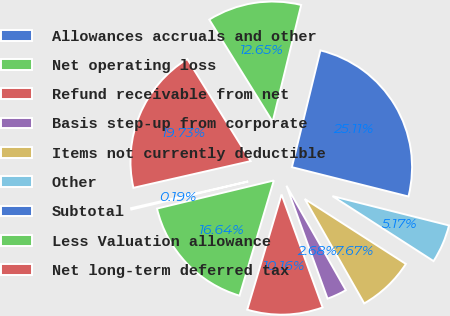Convert chart to OTSL. <chart><loc_0><loc_0><loc_500><loc_500><pie_chart><fcel>Allowances accruals and other<fcel>Net operating loss<fcel>Refund receivable from net<fcel>Basis step-up from corporate<fcel>Items not currently deductible<fcel>Other<fcel>Subtotal<fcel>Less Valuation allowance<fcel>Net long-term deferred tax<nl><fcel>0.19%<fcel>16.64%<fcel>10.16%<fcel>2.68%<fcel>7.67%<fcel>5.17%<fcel>25.11%<fcel>12.65%<fcel>19.73%<nl></chart> 